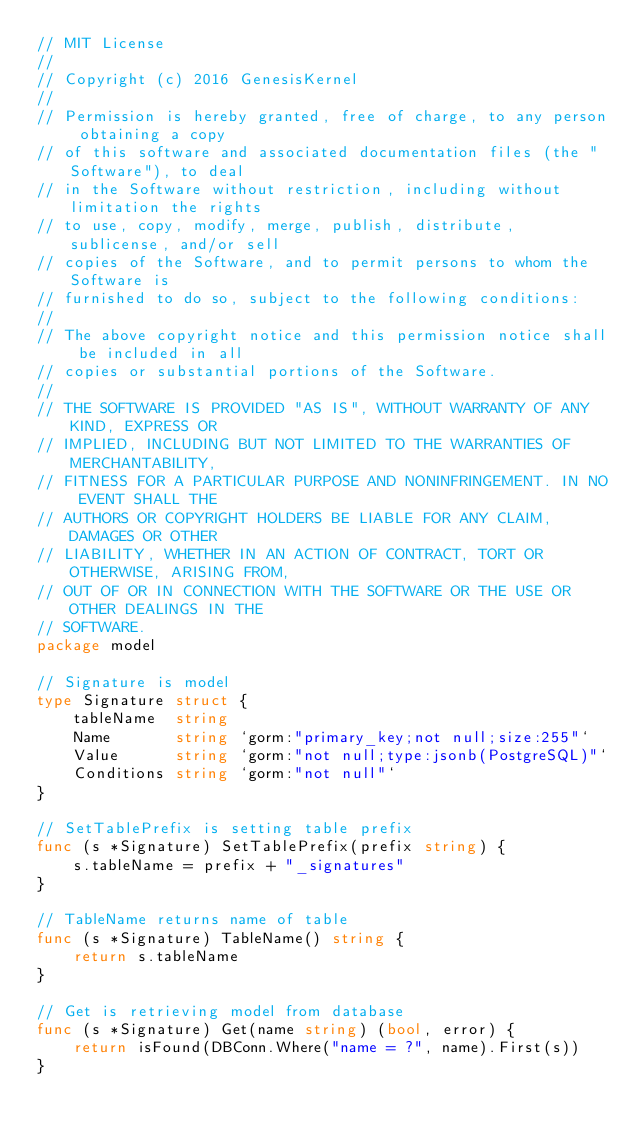Convert code to text. <code><loc_0><loc_0><loc_500><loc_500><_Go_>// MIT License
//
// Copyright (c) 2016 GenesisKernel
//
// Permission is hereby granted, free of charge, to any person obtaining a copy
// of this software and associated documentation files (the "Software"), to deal
// in the Software without restriction, including without limitation the rights
// to use, copy, modify, merge, publish, distribute, sublicense, and/or sell
// copies of the Software, and to permit persons to whom the Software is
// furnished to do so, subject to the following conditions:
//
// The above copyright notice and this permission notice shall be included in all
// copies or substantial portions of the Software.
//
// THE SOFTWARE IS PROVIDED "AS IS", WITHOUT WARRANTY OF ANY KIND, EXPRESS OR
// IMPLIED, INCLUDING BUT NOT LIMITED TO THE WARRANTIES OF MERCHANTABILITY,
// FITNESS FOR A PARTICULAR PURPOSE AND NONINFRINGEMENT. IN NO EVENT SHALL THE
// AUTHORS OR COPYRIGHT HOLDERS BE LIABLE FOR ANY CLAIM, DAMAGES OR OTHER
// LIABILITY, WHETHER IN AN ACTION OF CONTRACT, TORT OR OTHERWISE, ARISING FROM,
// OUT OF OR IN CONNECTION WITH THE SOFTWARE OR THE USE OR OTHER DEALINGS IN THE
// SOFTWARE.
package model

// Signature is model
type Signature struct {
	tableName  string
	Name       string `gorm:"primary_key;not null;size:255"`
	Value      string `gorm:"not null;type:jsonb(PostgreSQL)"`
	Conditions string `gorm:"not null"`
}

// SetTablePrefix is setting table prefix
func (s *Signature) SetTablePrefix(prefix string) {
	s.tableName = prefix + "_signatures"
}

// TableName returns name of table
func (s *Signature) TableName() string {
	return s.tableName
}

// Get is retrieving model from database
func (s *Signature) Get(name string) (bool, error) {
	return isFound(DBConn.Where("name = ?", name).First(s))
}
</code> 